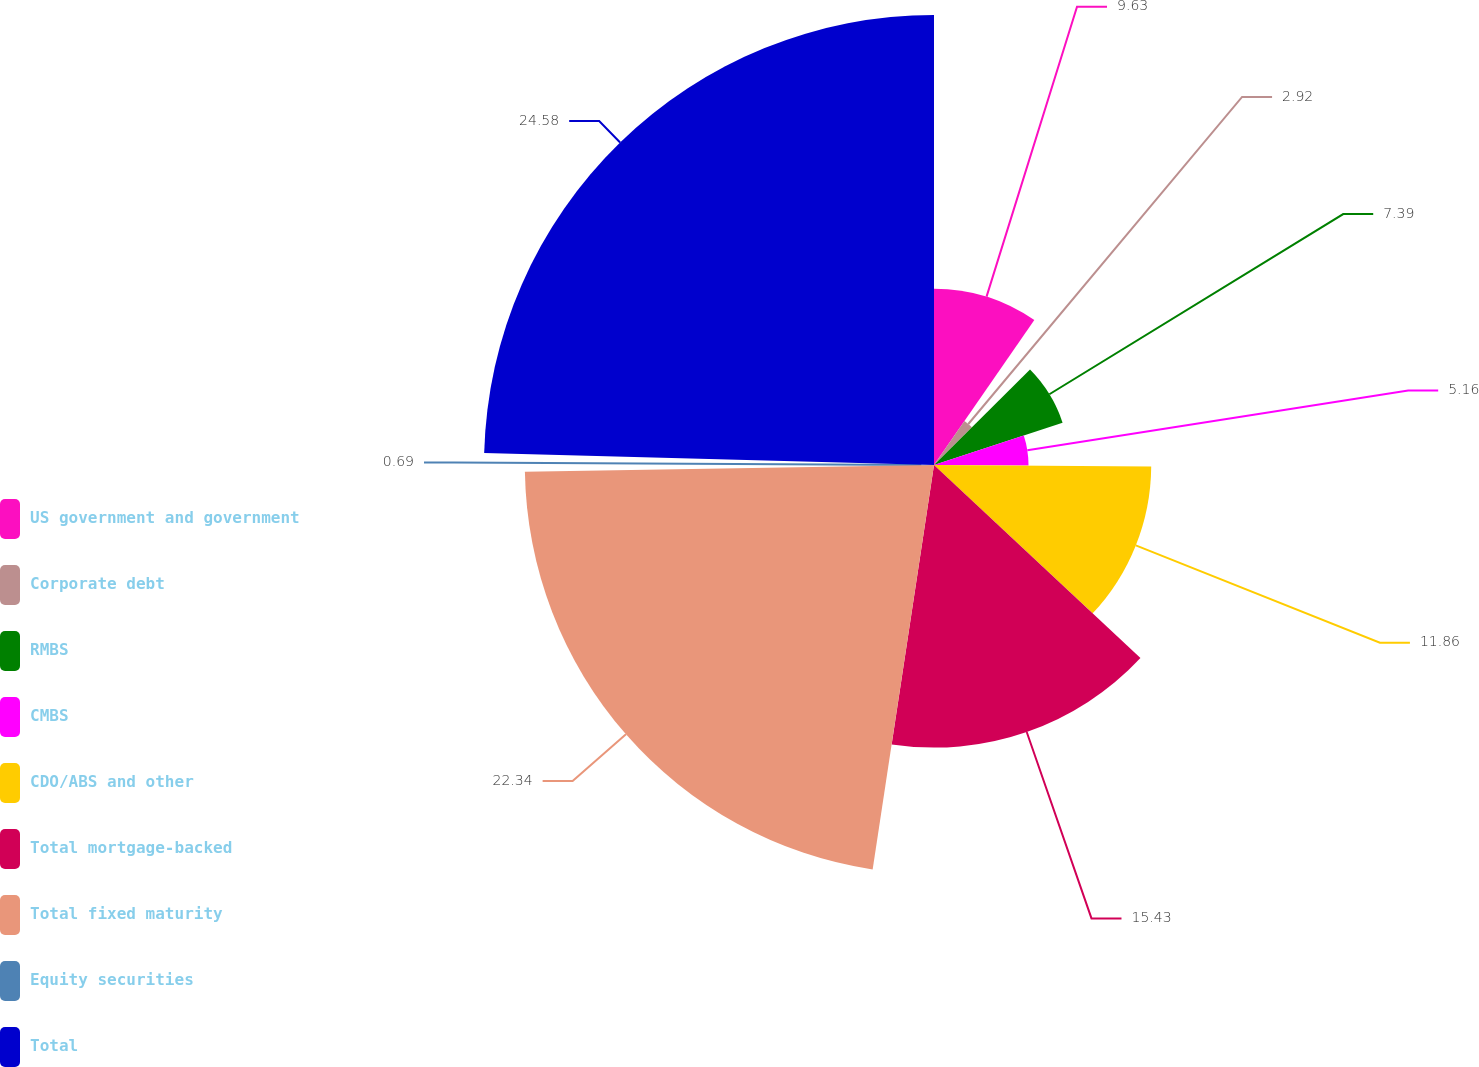Convert chart to OTSL. <chart><loc_0><loc_0><loc_500><loc_500><pie_chart><fcel>US government and government<fcel>Corporate debt<fcel>RMBS<fcel>CMBS<fcel>CDO/ABS and other<fcel>Total mortgage-backed<fcel>Total fixed maturity<fcel>Equity securities<fcel>Total<nl><fcel>9.63%<fcel>2.92%<fcel>7.39%<fcel>5.16%<fcel>11.86%<fcel>15.43%<fcel>22.34%<fcel>0.69%<fcel>24.57%<nl></chart> 